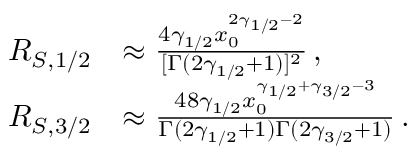<formula> <loc_0><loc_0><loc_500><loc_500>\begin{array} { r l } { R _ { S , 1 / 2 } } & { \approx \frac { 4 \gamma _ { 1 / 2 } x _ { 0 } ^ { 2 \gamma _ { 1 / 2 } - 2 } } { [ \Gamma ( 2 \gamma _ { 1 / 2 } + 1 ) ] ^ { 2 } } \, , } \\ { R _ { S , 3 / 2 } } & { \approx \frac { 4 8 \gamma _ { 1 / 2 } x _ { 0 } ^ { \gamma _ { 1 / 2 } + \gamma _ { 3 / 2 } - 3 } } { \Gamma ( 2 \gamma _ { 1 / 2 } + 1 ) \Gamma ( 2 \gamma _ { 3 / 2 } + 1 ) } \, . } \end{array}</formula> 